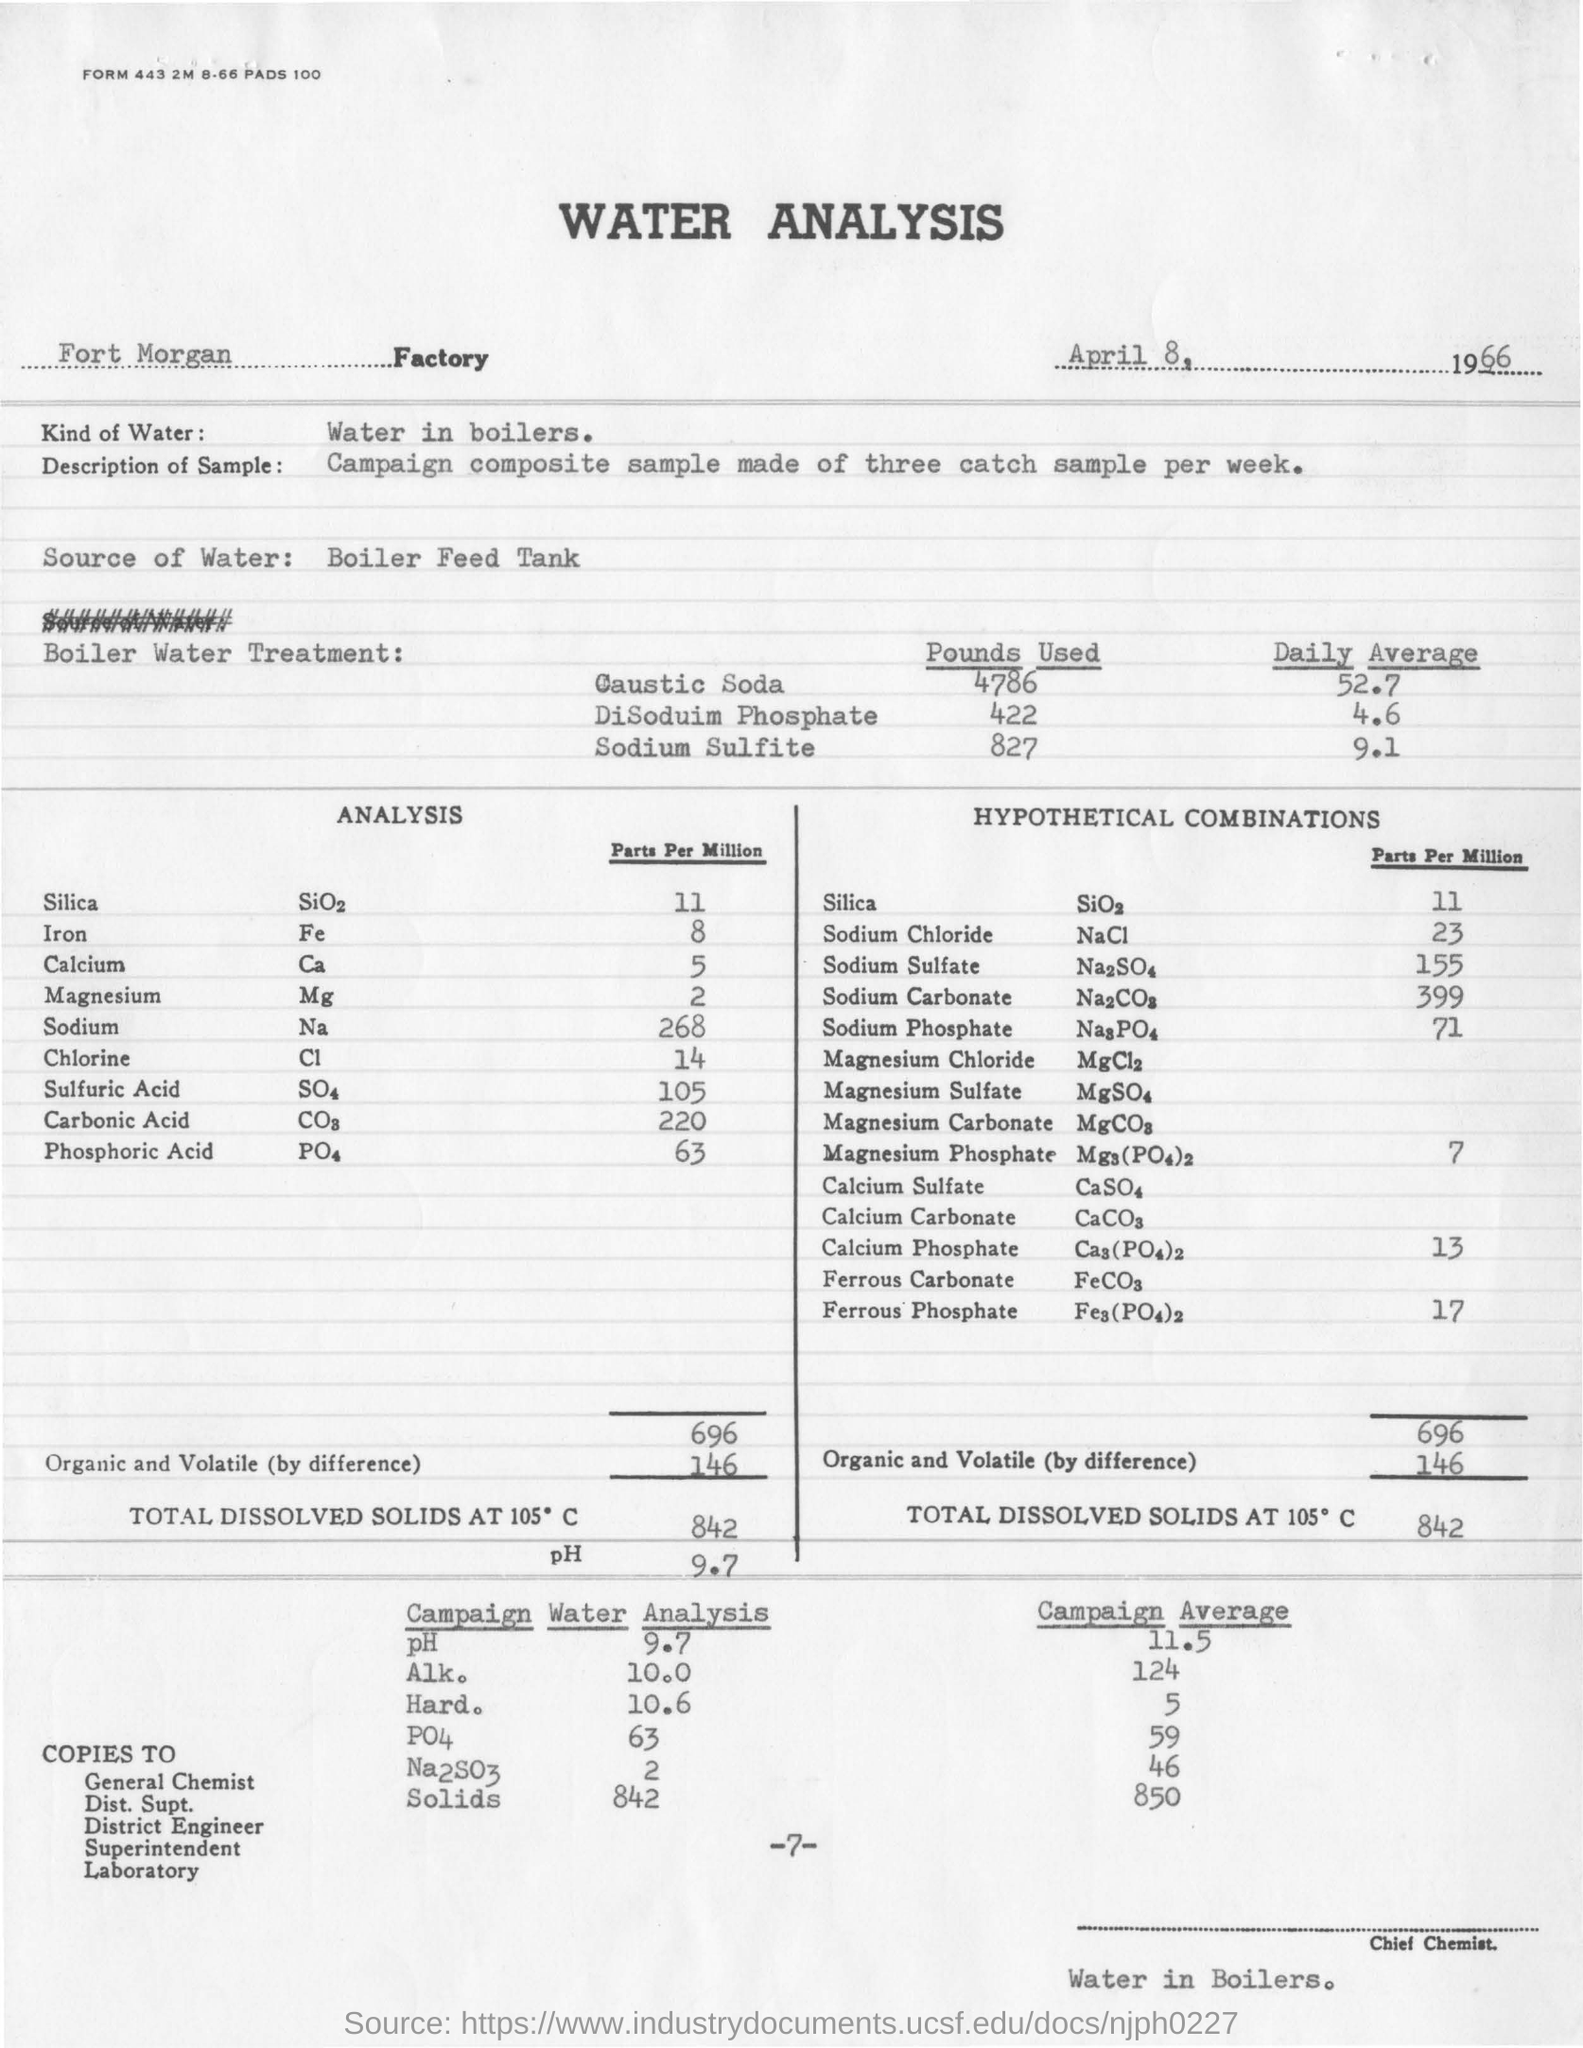Identify some key points in this picture. The daily average value of sodium sulfite used in boiler water treatment is 9.1. The amount of caustic soda used in boiler water treatment is approximately 4786 pounds. The pH value obtained in the water analysis was 9.7. The Fort Morgan factory is the name of the factory. The type of water used in the analysis is boiler water. 